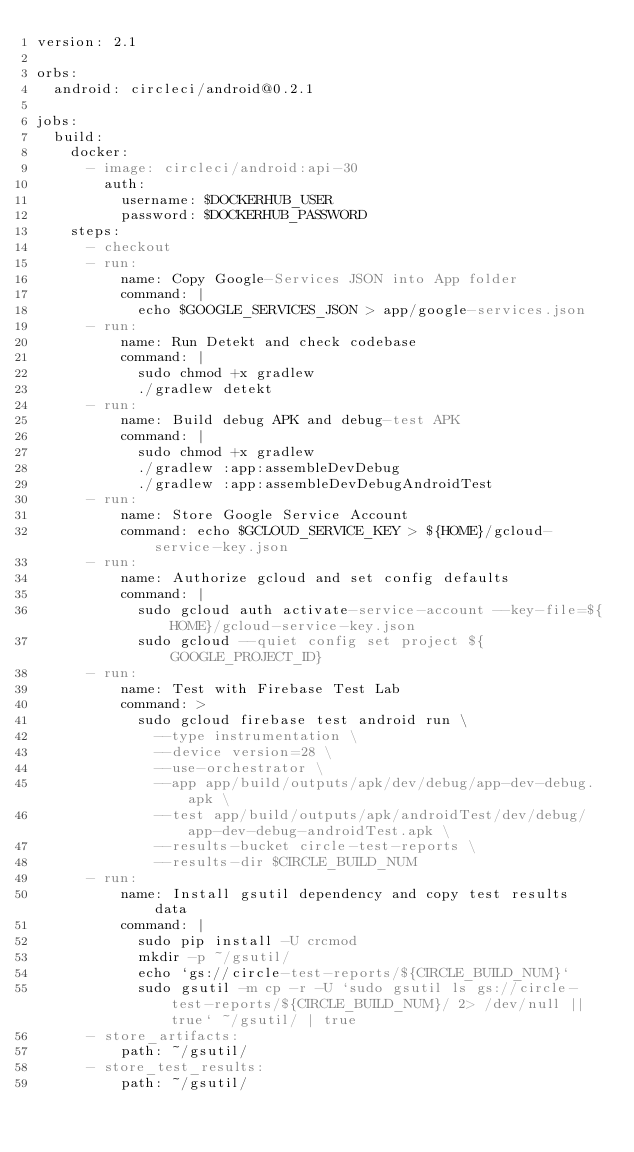<code> <loc_0><loc_0><loc_500><loc_500><_YAML_>version: 2.1

orbs:
  android: circleci/android@0.2.1

jobs:
  build:
    docker:
      - image: circleci/android:api-30
        auth:
          username: $DOCKERHUB_USER
          password: $DOCKERHUB_PASSWORD
    steps:
      - checkout
      - run:
          name: Copy Google-Services JSON into App folder
          command: |
            echo $GOOGLE_SERVICES_JSON > app/google-services.json
      - run:
          name: Run Detekt and check codebase
          command: |
            sudo chmod +x gradlew
            ./gradlew detekt
      - run:
          name: Build debug APK and debug-test APK
          command: |
            sudo chmod +x gradlew
            ./gradlew :app:assembleDevDebug
            ./gradlew :app:assembleDevDebugAndroidTest
      - run:
          name: Store Google Service Account
          command: echo $GCLOUD_SERVICE_KEY > ${HOME}/gcloud-service-key.json
      - run:
          name: Authorize gcloud and set config defaults
          command: |
            sudo gcloud auth activate-service-account --key-file=${HOME}/gcloud-service-key.json
            sudo gcloud --quiet config set project ${GOOGLE_PROJECT_ID}
      - run:
          name: Test with Firebase Test Lab
          command: >
            sudo gcloud firebase test android run \
              --type instrumentation \
              --device version=28 \
              --use-orchestrator \
              --app app/build/outputs/apk/dev/debug/app-dev-debug.apk \
              --test app/build/outputs/apk/androidTest/dev/debug/app-dev-debug-androidTest.apk \
              --results-bucket circle-test-reports \
              --results-dir $CIRCLE_BUILD_NUM
      - run:
          name: Install gsutil dependency and copy test results data
          command: |
            sudo pip install -U crcmod
            mkdir -p ~/gsutil/
            echo `gs://circle-test-reports/${CIRCLE_BUILD_NUM}`
            sudo gsutil -m cp -r -U `sudo gsutil ls gs://circle-test-reports/${CIRCLE_BUILD_NUM}/ 2> /dev/null || true` ~/gsutil/ | true
      - store_artifacts:
          path: ~/gsutil/
      - store_test_results:
          path: ~/gsutil/
</code> 